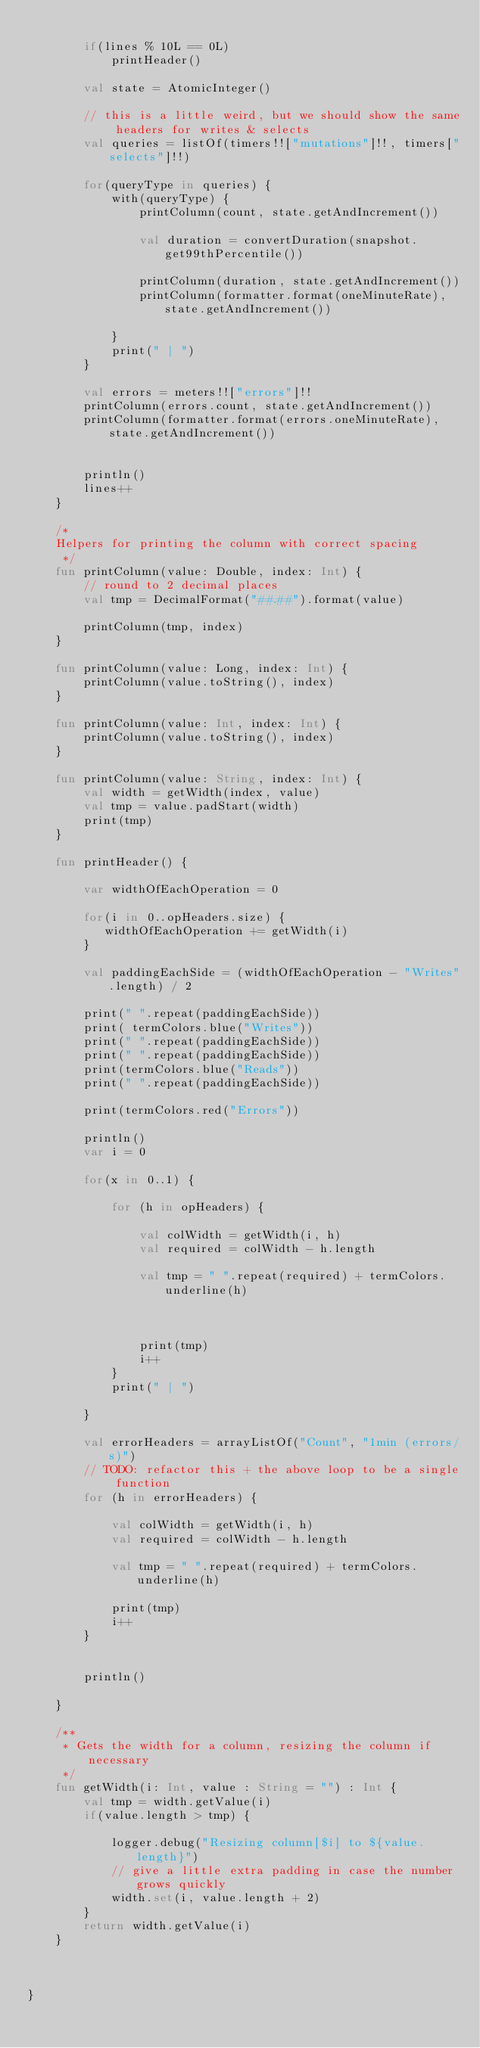Convert code to text. <code><loc_0><loc_0><loc_500><loc_500><_Kotlin_>
        if(lines % 10L == 0L)
            printHeader()

        val state = AtomicInteger()

        // this is a little weird, but we should show the same headers for writes & selects
        val queries = listOf(timers!!["mutations"]!!, timers["selects"]!!)

        for(queryType in queries) {
            with(queryType) {
                printColumn(count, state.getAndIncrement())

                val duration = convertDuration(snapshot.get99thPercentile())

                printColumn(duration, state.getAndIncrement())
                printColumn(formatter.format(oneMinuteRate), state.getAndIncrement())

            }
            print(" | ")
        }

        val errors = meters!!["errors"]!!
        printColumn(errors.count, state.getAndIncrement())
        printColumn(formatter.format(errors.oneMinuteRate), state.getAndIncrement())


        println()
        lines++
    }

    /*
    Helpers for printing the column with correct spacing
     */
    fun printColumn(value: Double, index: Int) {
        // round to 2 decimal places
        val tmp = DecimalFormat("##.##").format(value)

        printColumn(tmp, index)
    }

    fun printColumn(value: Long, index: Int) {
        printColumn(value.toString(), index)
    }

    fun printColumn(value: Int, index: Int) {
        printColumn(value.toString(), index)
    }

    fun printColumn(value: String, index: Int) {
        val width = getWidth(index, value)
        val tmp = value.padStart(width)
        print(tmp)
    }

    fun printHeader() {

        var widthOfEachOperation = 0

        for(i in 0..opHeaders.size) {
           widthOfEachOperation += getWidth(i)
        }

        val paddingEachSide = (widthOfEachOperation - "Writes".length) / 2

        print(" ".repeat(paddingEachSide))
        print( termColors.blue("Writes"))
        print(" ".repeat(paddingEachSide))
        print(" ".repeat(paddingEachSide))
        print(termColors.blue("Reads"))
        print(" ".repeat(paddingEachSide))

        print(termColors.red("Errors"))

        println()
        var i = 0

        for(x in 0..1) {

            for (h in opHeaders) {

                val colWidth = getWidth(i, h)
                val required = colWidth - h.length

                val tmp = " ".repeat(required) + termColors.underline(h)



                print(tmp)
                i++
            }
            print(" | ")

        }

        val errorHeaders = arrayListOf("Count", "1min (errors/s)")
        // TODO: refactor this + the above loop to be a single function
        for (h in errorHeaders) {

            val colWidth = getWidth(i, h)
            val required = colWidth - h.length

            val tmp = " ".repeat(required) + termColors.underline(h)

            print(tmp)
            i++
        }


        println()

    }

    /**
     * Gets the width for a column, resizing the column if necessary
     */
    fun getWidth(i: Int, value : String = "") : Int {
        val tmp = width.getValue(i)
        if(value.length > tmp) {

            logger.debug("Resizing column[$i] to ${value.length}")
            // give a little extra padding in case the number grows quickly
            width.set(i, value.length + 2)
        }
        return width.getValue(i)
    }



}
</code> 